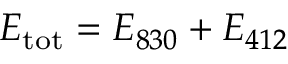Convert formula to latex. <formula><loc_0><loc_0><loc_500><loc_500>E _ { t o t } = E _ { 8 3 0 } + E _ { 4 1 2 }</formula> 